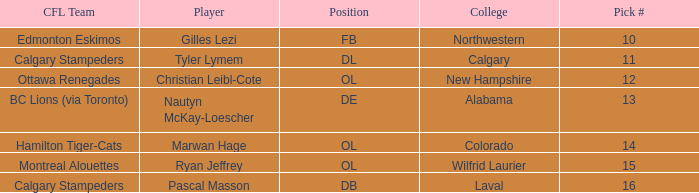What is the pick number for Northwestern college? 10.0. 